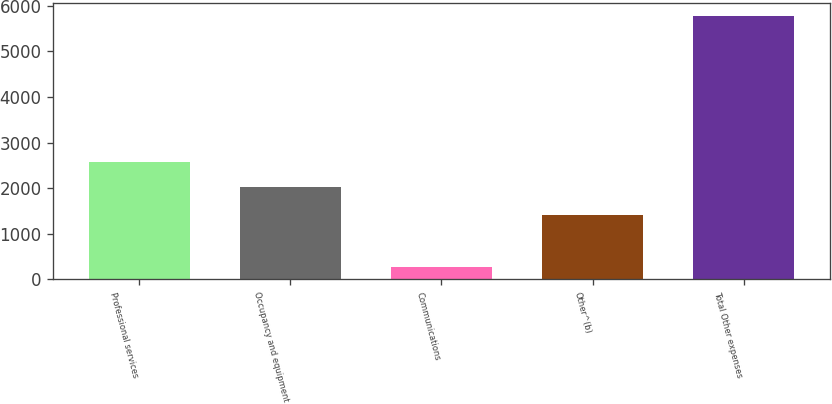<chart> <loc_0><loc_0><loc_500><loc_500><bar_chart><fcel>Professional services<fcel>Occupancy and equipment<fcel>Communications<fcel>Other^(b)<fcel>Total Other expenses<nl><fcel>2569<fcel>2019<fcel>276<fcel>1411<fcel>5776<nl></chart> 